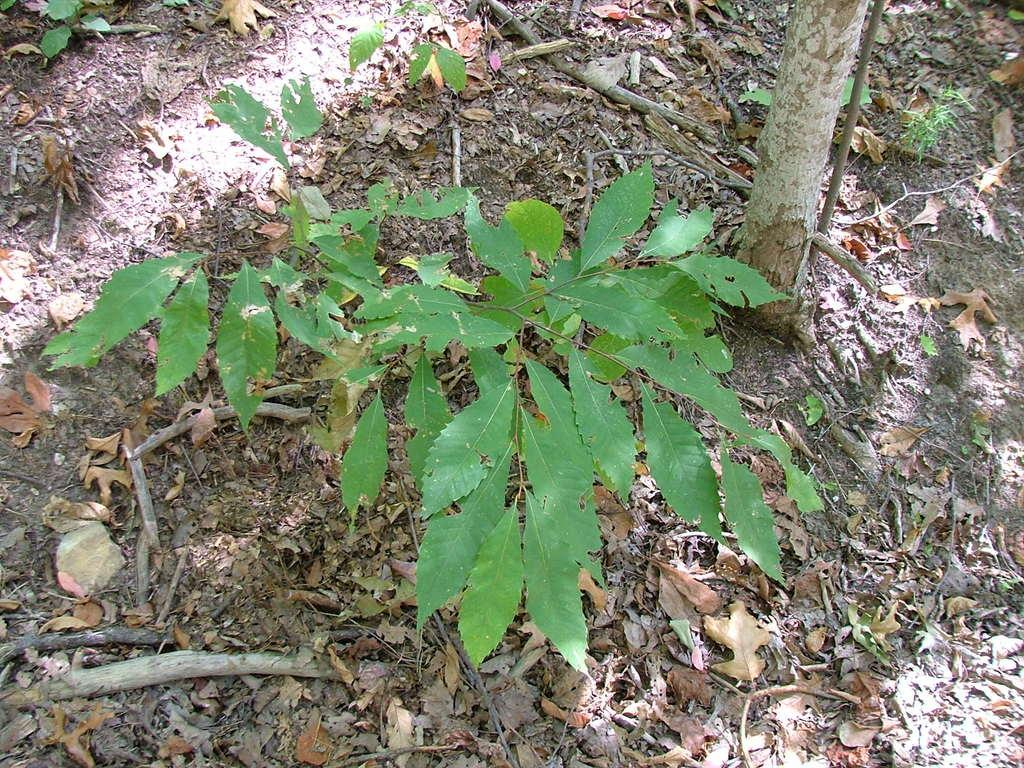What type of living organisms can be seen in the image? Plants can be seen in the image. What color are the plants in the image? The plants are green in color. What additional feature can be observed in the image related to the plants? There are dried leaves in the image. What color are the dried leaves in the image? The dried leaves are brown in color. Can you tell me how many teeth the plants have in the image? Plants do not have teeth, so this question cannot be answered based on the image. 